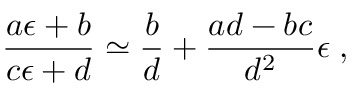Convert formula to latex. <formula><loc_0><loc_0><loc_500><loc_500>\frac { a \epsilon + b } { c \epsilon + d } \simeq \frac { b } { d } + \frac { a d - b c } { d ^ { 2 } } \epsilon \, ,</formula> 